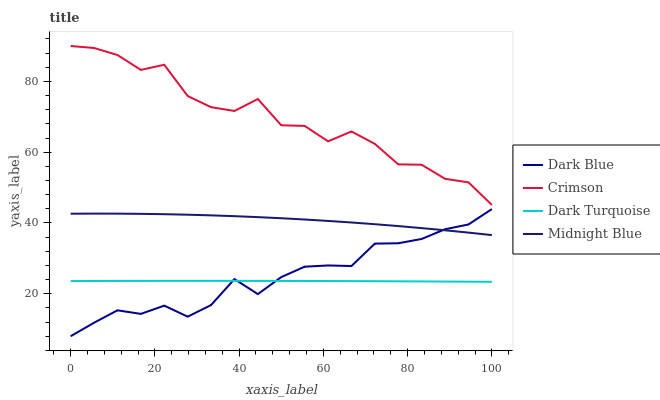Does Dark Turquoise have the minimum area under the curve?
Answer yes or no. Yes. Does Crimson have the maximum area under the curve?
Answer yes or no. Yes. Does Dark Blue have the minimum area under the curve?
Answer yes or no. No. Does Dark Blue have the maximum area under the curve?
Answer yes or no. No. Is Dark Turquoise the smoothest?
Answer yes or no. Yes. Is Crimson the roughest?
Answer yes or no. Yes. Is Dark Blue the smoothest?
Answer yes or no. No. Is Dark Blue the roughest?
Answer yes or no. No. Does Dark Blue have the lowest value?
Answer yes or no. Yes. Does Midnight Blue have the lowest value?
Answer yes or no. No. Does Crimson have the highest value?
Answer yes or no. Yes. Does Dark Blue have the highest value?
Answer yes or no. No. Is Midnight Blue less than Crimson?
Answer yes or no. Yes. Is Midnight Blue greater than Dark Turquoise?
Answer yes or no. Yes. Does Dark Blue intersect Midnight Blue?
Answer yes or no. Yes. Is Dark Blue less than Midnight Blue?
Answer yes or no. No. Is Dark Blue greater than Midnight Blue?
Answer yes or no. No. Does Midnight Blue intersect Crimson?
Answer yes or no. No. 